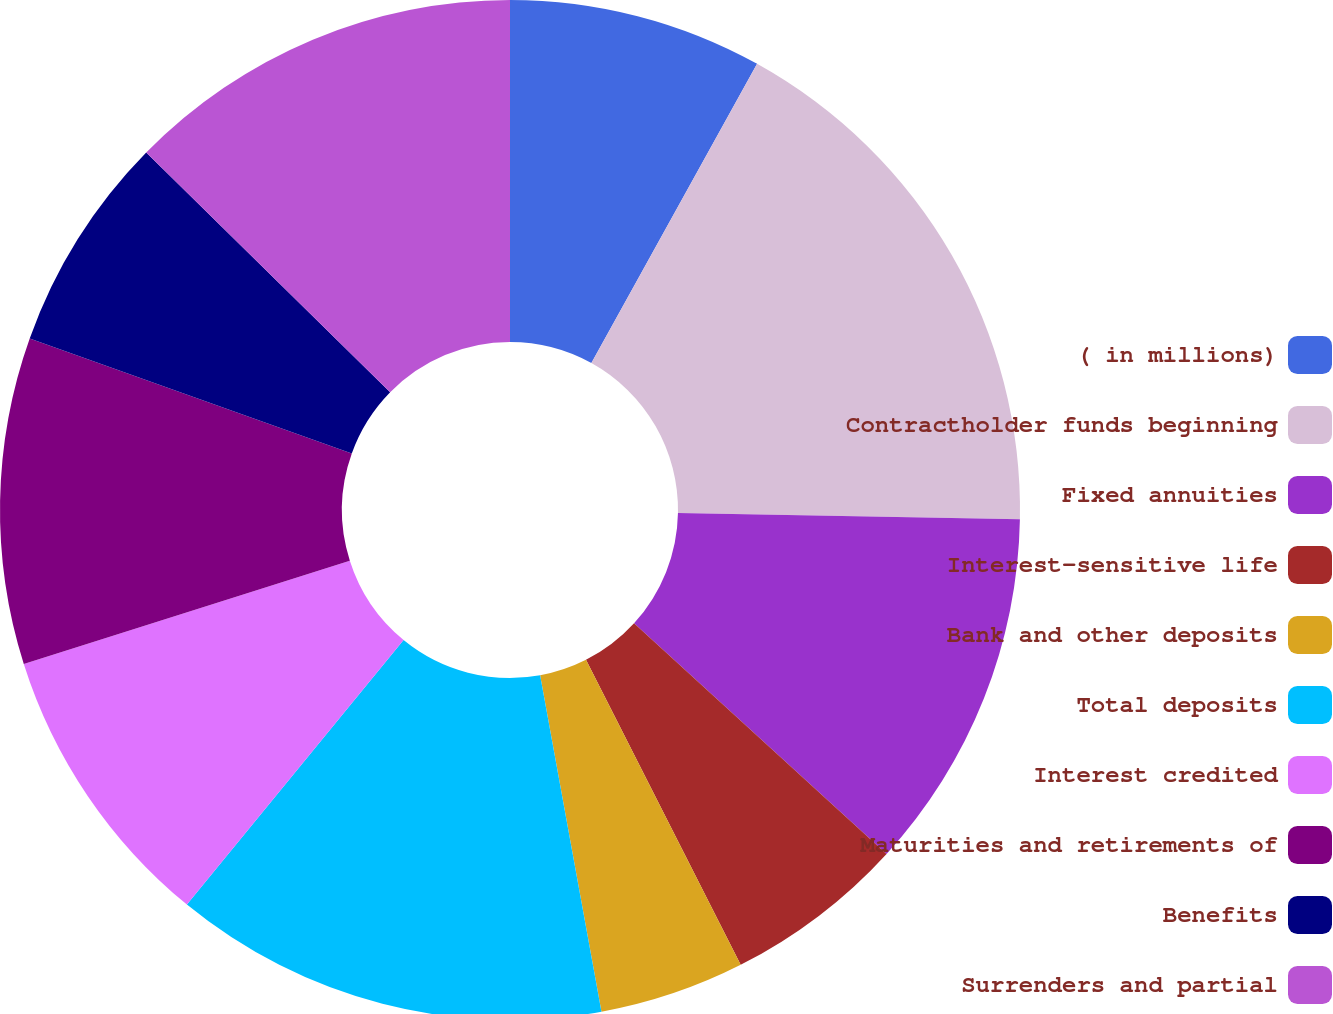Convert chart to OTSL. <chart><loc_0><loc_0><loc_500><loc_500><pie_chart><fcel>( in millions)<fcel>Contractholder funds beginning<fcel>Fixed annuities<fcel>Interest-sensitive life<fcel>Bank and other deposits<fcel>Total deposits<fcel>Interest credited<fcel>Maturities and retirements of<fcel>Benefits<fcel>Surrenders and partial<nl><fcel>8.05%<fcel>17.24%<fcel>11.49%<fcel>5.75%<fcel>4.6%<fcel>13.79%<fcel>9.2%<fcel>10.34%<fcel>6.9%<fcel>12.64%<nl></chart> 